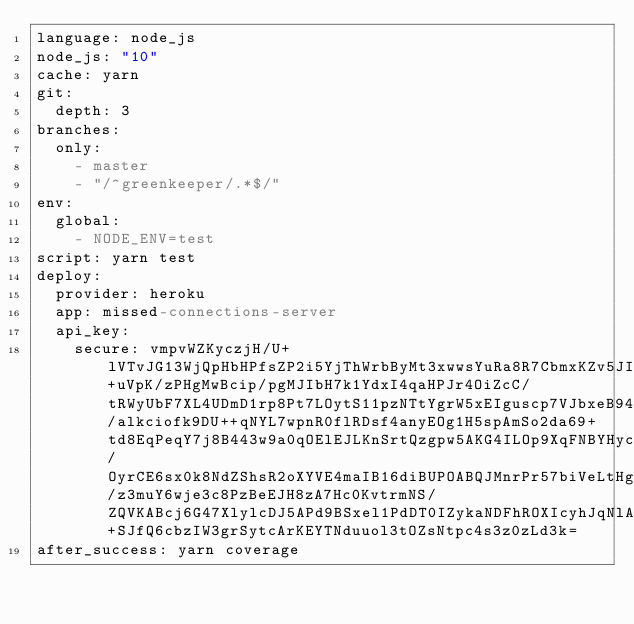Convert code to text. <code><loc_0><loc_0><loc_500><loc_500><_YAML_>language: node_js
node_js: "10"
cache: yarn
git:
  depth: 3
branches:
  only:
    - master
    - "/^greenkeeper/.*$/"
env:
  global:
    - NODE_ENV=test
script: yarn test
deploy:
  provider: heroku
  app: missed-connections-server
  api_key:
    secure: vmpvWZKyczjH/U+lVTvJG13WjQpHbHPfsZP2i5YjThWrbByMt3xwwsYuRa8R7CbmxKZv5JIggLyMHeGO9O4cLmoZY80SARQAKMdGtnTGM2t+uVpK/zPHgMwBcip/pgMJIbH7k1YdxI4qaHPJr4OiZcC/tRWyUbF7XL4UDmD1rp8Pt7LOytS11pzNTtYgrW5xEIguscp7VJbxeB94MCmsS9sJMz7RGrEUQF/alkciofk9DU++qNYL7wpnR0flRDsf4anyEOg1H5spAmSo2da69+td8EqPeqY7j8B443w9a0qOElEJLKnSrtQzgpw5AKG4ILOp9XqFNBYHycen8NFFo0f6zBHVro4l8txD3ngXw5wYTms41fYBiiVe9Ll7q8JpI/OyrCE6sx0k8NdZShsR2oXYVE4maIB16diBUPOABQJMnrPr57biVeLtHgj3NMf0U39YgCJ4obln2vi09yNlo68ZK9Amm/z3muY6wje3c8PzBeEJH8zA7Hc0KvtrmNS/ZQVKABcj6G47XlylcDJ5APd9BSxel1PdDT0IZykaNDFhROXIcyhJqNlAgXXcKrs9as6v4x4KjI5uKIVzNRoPds160HH8zZ30FNtPNTD3uzvghc7NBdwjopEMOg+SJfQ6cbzIW3grSytcArKEYTNduuol3tOZsNtpc4s3z0zLd3k=
after_success: yarn coverage
</code> 